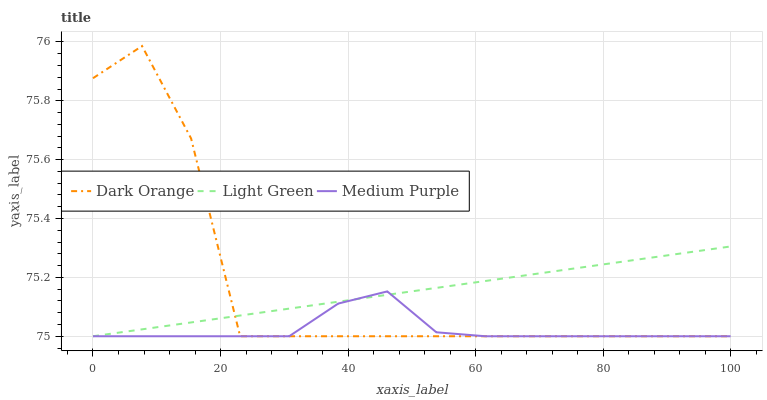Does Light Green have the minimum area under the curve?
Answer yes or no. No. Does Light Green have the maximum area under the curve?
Answer yes or no. No. Is Dark Orange the smoothest?
Answer yes or no. No. Is Light Green the roughest?
Answer yes or no. No. Does Light Green have the highest value?
Answer yes or no. No. 